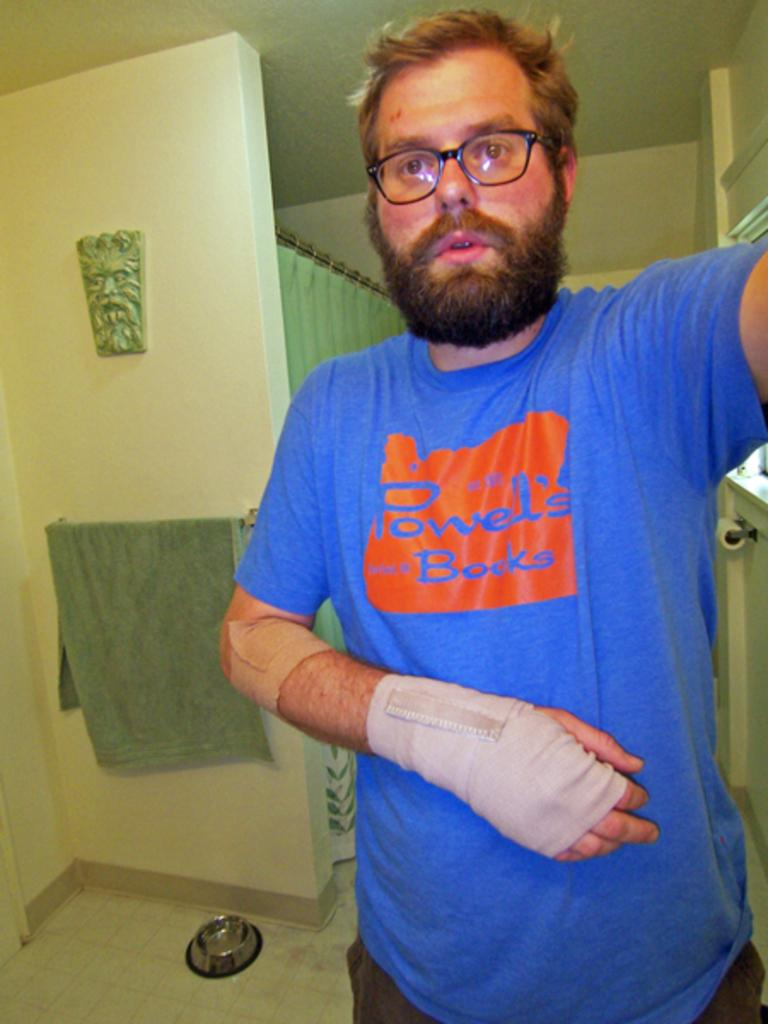What is the main subject of the image? There is a person standing in the image. Can you describe any accessories or items the person is wearing or holding? The person has a band tied to their hand. What can be seen in the background of the image? There is a wall, a curtain attached to a rod, a towel, a roll of tissue, and a few unspecified objects in the background. Can you tell me how many kitties are playing with the quilt in the image? There are no kitties or quilts present in the image. What color is the chalk used by the person in the image? There is no chalk visible in the image. 